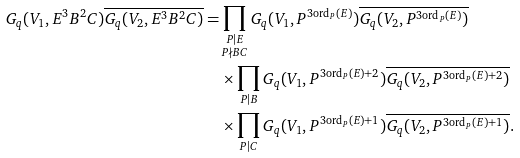Convert formula to latex. <formula><loc_0><loc_0><loc_500><loc_500>G _ { q } ( V _ { 1 } , E ^ { 3 } B ^ { 2 } C ) \overline { G _ { q } ( V _ { 2 } , E ^ { 3 } B ^ { 2 } C ) } = & \prod _ { \substack { P | E \\ P \nmid B C } } G _ { q } ( V _ { 1 } , P ^ { 3 \text {ord} _ { P } ( E ) } ) \overline { G _ { q } ( V _ { 2 } , P ^ { 3 \text {ord} _ { P } ( E ) } ) } \\ & \times \prod _ { P | B } G _ { q } ( V _ { 1 } , P ^ { 3 \text {ord} _ { P } ( E ) + 2 } ) \overline { G _ { q } ( V _ { 2 } , P ^ { 3 \text {ord} _ { P } ( E ) + 2 } ) } \\ & \times \prod _ { P | C } G _ { q } ( V _ { 1 } , P ^ { 3 \text {ord} _ { P } ( E ) + 1 } ) \overline { G _ { q } ( V _ { 2 } , P ^ { 3 \text {ord} _ { P } ( E ) + 1 } ) } .</formula> 